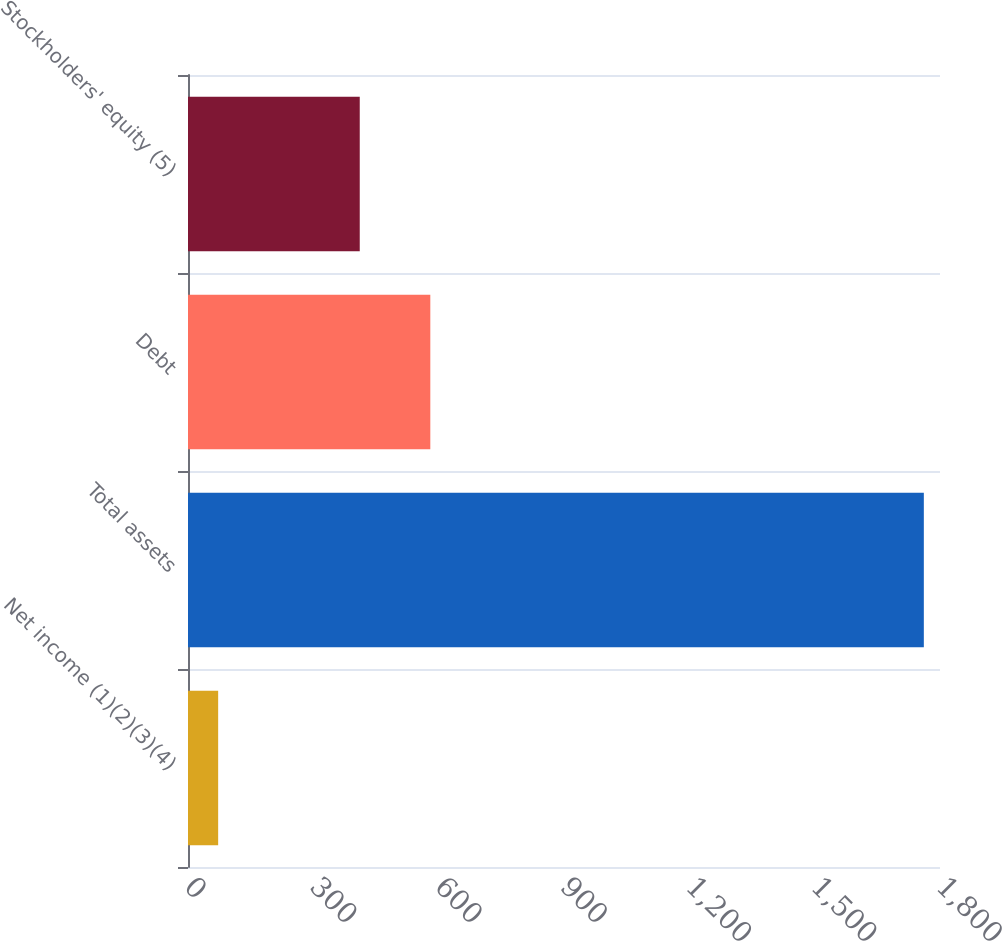<chart> <loc_0><loc_0><loc_500><loc_500><bar_chart><fcel>Net income (1)(2)(3)(4)<fcel>Total assets<fcel>Debt<fcel>Stockholders' equity (5)<nl><fcel>72.2<fcel>1761.3<fcel>580.01<fcel>411.1<nl></chart> 